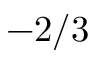<formula> <loc_0><loc_0><loc_500><loc_500>- 2 / 3</formula> 